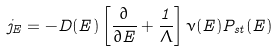Convert formula to latex. <formula><loc_0><loc_0><loc_500><loc_500>j _ { E } = - D ( E ) \left [ \frac { \partial } { \partial E } + \frac { 1 } { \Lambda } \right ] \nu ( E ) P _ { s t } ( E )</formula> 